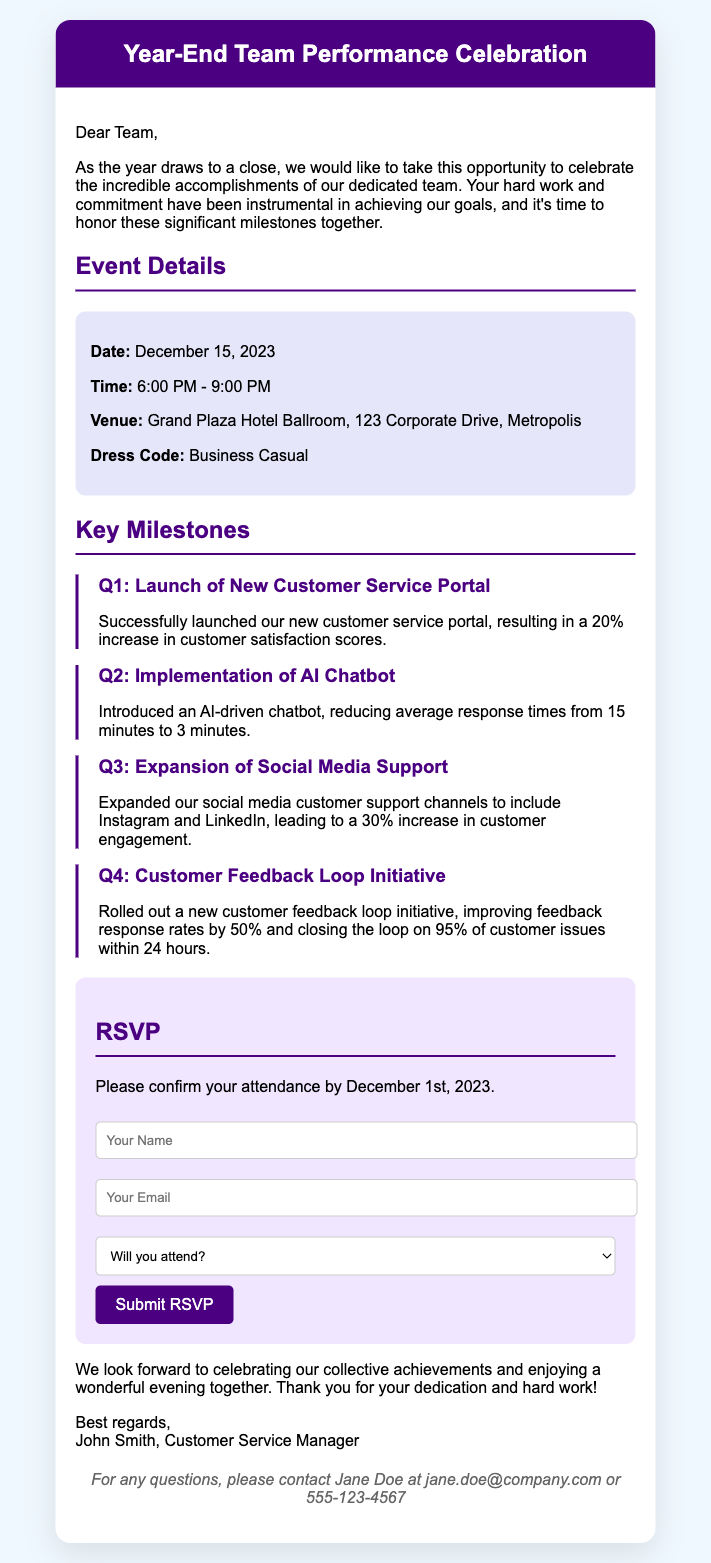what is the date of the event? The event is scheduled to take place on December 15, 2023.
Answer: December 15, 2023 what is the venue for the celebration? The celebration will be held at the Grand Plaza Hotel Ballroom.
Answer: Grand Plaza Hotel Ballroom what time does the event start? The event begins at 6:00 PM.
Answer: 6:00 PM what is the dress code for the event? The document specifies that the dress code is Business Casual.
Answer: Business Casual how much has customer satisfaction increased due to the new customer service portal? The document mentions a 20% increase in customer satisfaction scores.
Answer: 20% how many responses were closed within 24 hours in Q4's initiative? According to the document, 95% of customer issues were closed within 24 hours.
Answer: 95% who should be contacted for questions regarding the event? The document states to contact Jane Doe for any questions.
Answer: Jane Doe when is the RSVP deadline? The RSVP needs to be confirmed by December 1, 2023.
Answer: December 1, 2023 what initiative was launched in Q2? The document mentions the implementation of an AI Chatbot.
Answer: AI Chatbot 